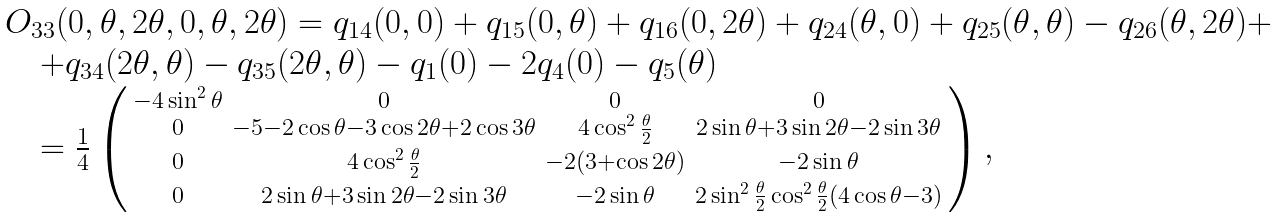<formula> <loc_0><loc_0><loc_500><loc_500>\begin{array} { l l l } & O _ { 3 3 } ( 0 , \theta , 2 \theta , 0 , \theta , 2 \theta ) = q _ { 1 4 } ( 0 , 0 ) + q _ { 1 5 } ( 0 , \theta ) + q _ { 1 6 } ( 0 , 2 \theta ) + q _ { 2 4 } ( \theta , 0 ) + q _ { 2 5 } ( \theta , \theta ) - q _ { 2 6 } ( \theta , 2 \theta ) + \\ & \quad + q _ { 3 4 } ( 2 \theta , \theta ) - q _ { 3 5 } ( 2 \theta , \theta ) - q _ { 1 } ( 0 ) - 2 q _ { 4 } ( 0 ) - q _ { 5 } ( \theta ) \\ & \quad = \frac { 1 } { 4 } \left ( \begin{smallmatrix} - 4 \sin ^ { 2 } \theta & 0 & 0 & 0 \\ 0 & - 5 - 2 \cos \theta - 3 \cos 2 \theta + 2 \cos 3 \theta & 4 \cos ^ { 2 } \frac { \theta } { 2 } & 2 \sin \theta + 3 \sin 2 \theta - 2 \sin 3 \theta \\ 0 & 4 \cos ^ { 2 } \frac { \theta } { 2 } & - 2 ( 3 + \cos 2 \theta ) & - 2 \sin \theta \\ 0 & 2 \sin \theta + 3 \sin 2 \theta - 2 \sin 3 \theta & - 2 \sin \theta & 2 \sin ^ { 2 } \frac { \theta } { 2 } \cos ^ { 2 } \frac { \theta } { 2 } ( 4 \cos \theta - 3 ) \end{smallmatrix} \right ) , \end{array}</formula> 